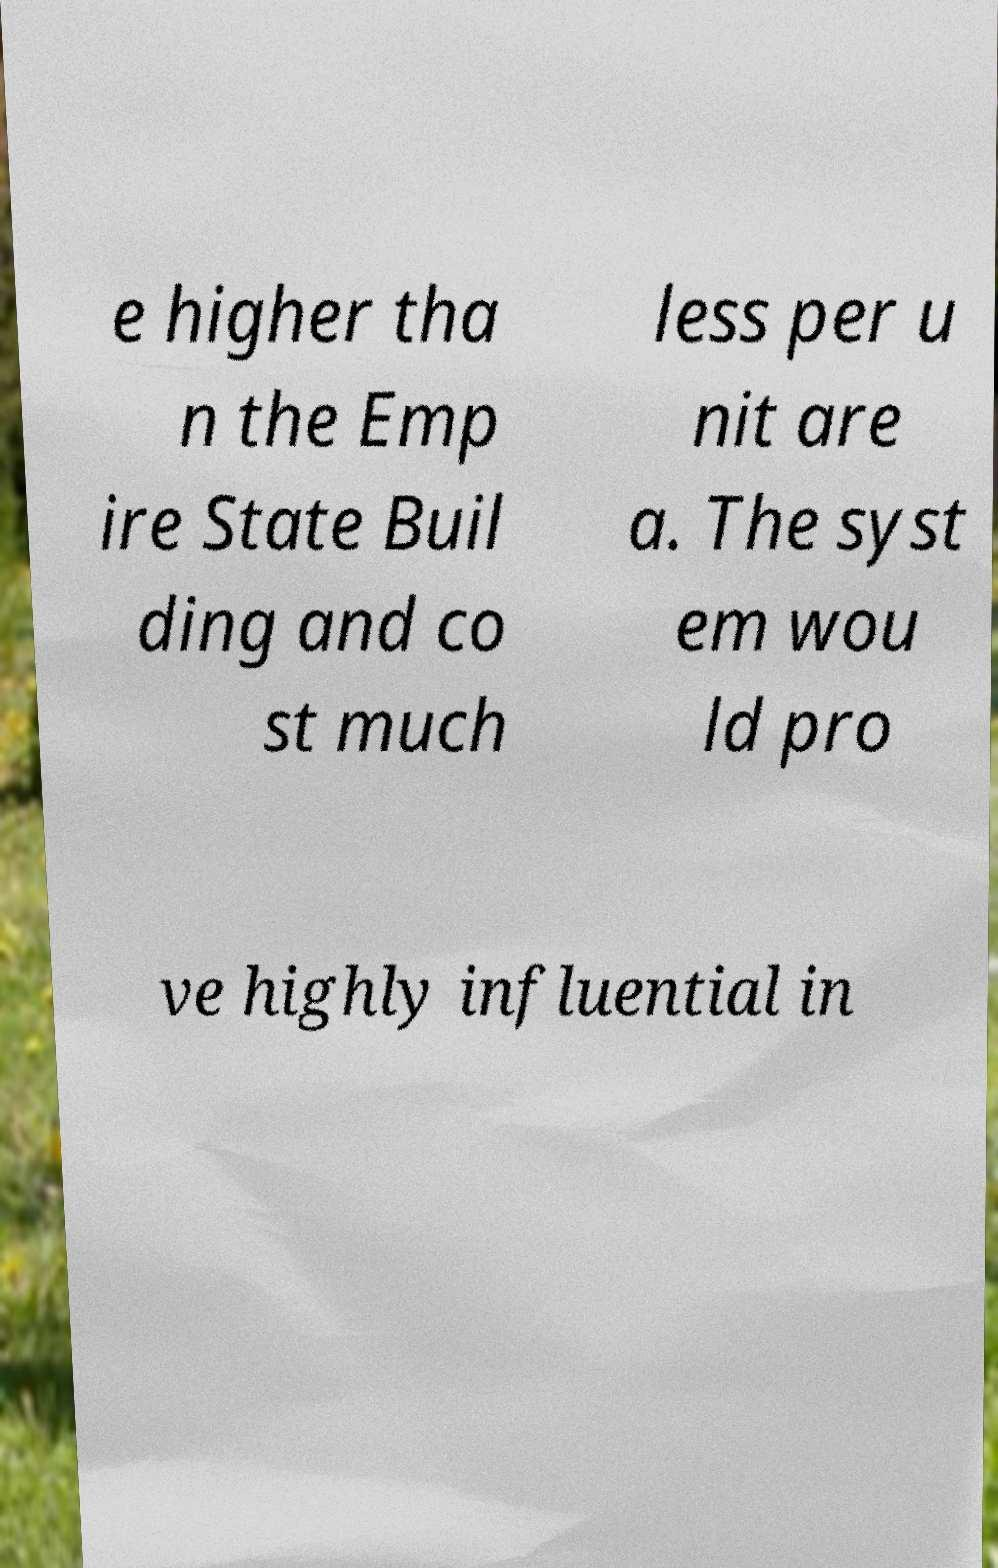I need the written content from this picture converted into text. Can you do that? e higher tha n the Emp ire State Buil ding and co st much less per u nit are a. The syst em wou ld pro ve highly influential in 